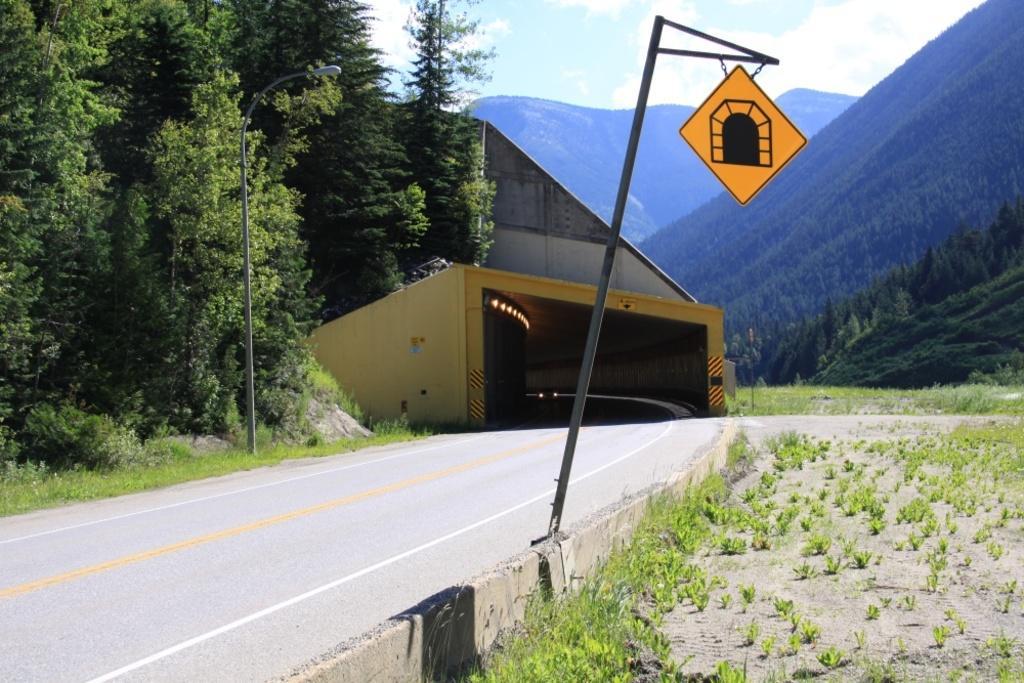Can you describe this image briefly? In this image I can see the board hanged to the pole. In the background I can see the light pole, few trees in green color, few lights, mountains and the sky is in white and blue color. 